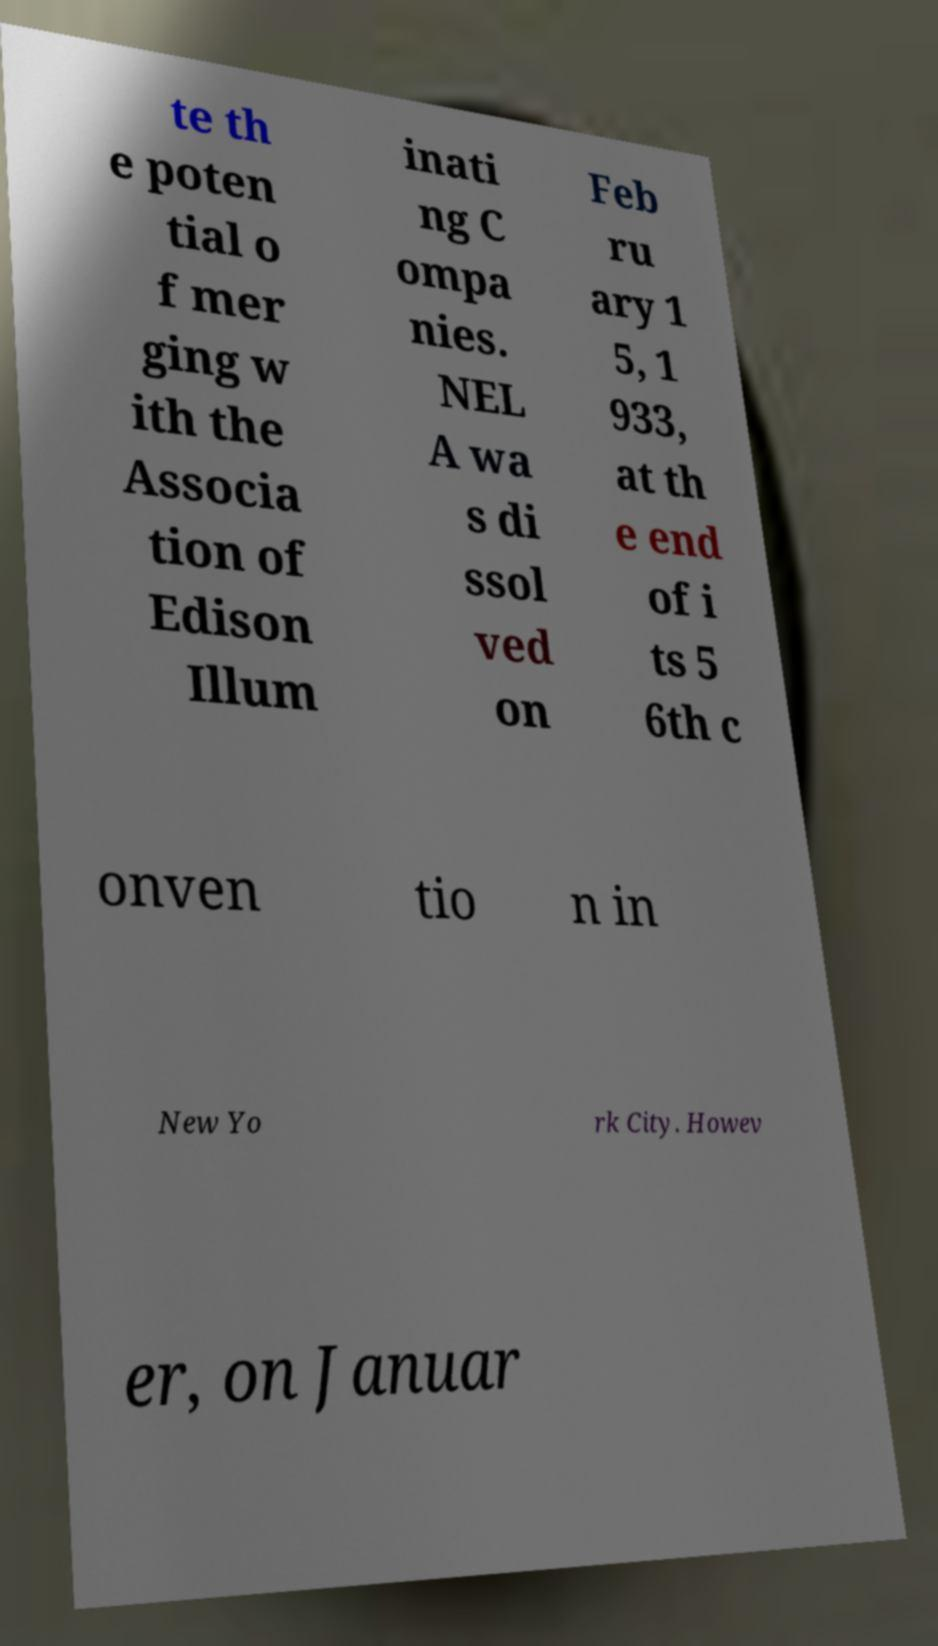I need the written content from this picture converted into text. Can you do that? te th e poten tial o f mer ging w ith the Associa tion of Edison Illum inati ng C ompa nies. NEL A wa s di ssol ved on Feb ru ary 1 5, 1 933, at th e end of i ts 5 6th c onven tio n in New Yo rk City. Howev er, on Januar 